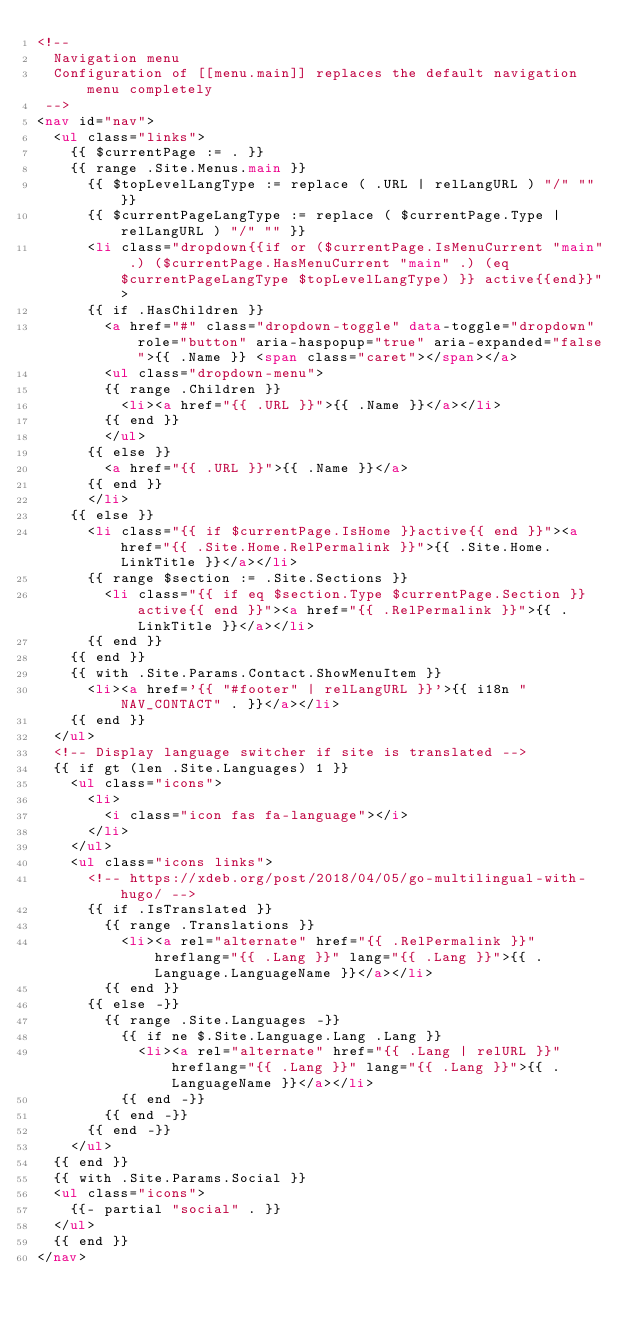Convert code to text. <code><loc_0><loc_0><loc_500><loc_500><_HTML_><!--
  Navigation menu
  Configuration of [[menu.main]] replaces the default navigation menu completely
 -->
<nav id="nav">
  <ul class="links">
    {{ $currentPage := . }}
    {{ range .Site.Menus.main }}
      {{ $topLevelLangType := replace ( .URL | relLangURL ) "/" "" }}
      {{ $currentPageLangType := replace ( $currentPage.Type | relLangURL ) "/" "" }}
      <li class="dropdown{{if or ($currentPage.IsMenuCurrent "main" .) ($currentPage.HasMenuCurrent "main" .) (eq $currentPageLangType $topLevelLangType) }} active{{end}}">
      {{ if .HasChildren }}
        <a href="#" class="dropdown-toggle" data-toggle="dropdown" role="button" aria-haspopup="true" aria-expanded="false">{{ .Name }} <span class="caret"></span></a>
        <ul class="dropdown-menu">
        {{ range .Children }}
          <li><a href="{{ .URL }}">{{ .Name }}</a></li>
        {{ end }}
        </ul>
      {{ else }}
        <a href="{{ .URL }}">{{ .Name }}</a>
      {{ end }}
      </li>
    {{ else }}
      <li class="{{ if $currentPage.IsHome }}active{{ end }}"><a href="{{ .Site.Home.RelPermalink }}">{{ .Site.Home.LinkTitle }}</a></li>
      {{ range $section := .Site.Sections }}
        <li class="{{ if eq $section.Type $currentPage.Section }}active{{ end }}"><a href="{{ .RelPermalink }}">{{ .LinkTitle }}</a></li>
      {{ end }}
    {{ end }}
    {{ with .Site.Params.Contact.ShowMenuItem }}
      <li><a href='{{ "#footer" | relLangURL }}'>{{ i18n "NAV_CONTACT" . }}</a></li>
    {{ end }}
  </ul>
  <!-- Display language switcher if site is translated -->
  {{ if gt (len .Site.Languages) 1 }}
    <ul class="icons">
      <li>
        <i class="icon fas fa-language"></i>
      </li>
    </ul>
    <ul class="icons links">
      <!-- https://xdeb.org/post/2018/04/05/go-multilingual-with-hugo/ -->
      {{ if .IsTranslated }}
        {{ range .Translations }}
          <li><a rel="alternate" href="{{ .RelPermalink }}" hreflang="{{ .Lang }}" lang="{{ .Lang }}">{{ .Language.LanguageName }}</a></li>
        {{ end }}
      {{ else -}}
        {{ range .Site.Languages -}}
          {{ if ne $.Site.Language.Lang .Lang }}
            <li><a rel="alternate" href="{{ .Lang | relURL }}" hreflang="{{ .Lang }}" lang="{{ .Lang }}">{{ .LanguageName }}</a></li>
          {{ end -}}
        {{ end -}}
      {{ end -}}
    </ul>
  {{ end }}
  {{ with .Site.Params.Social }}
  <ul class="icons">
    {{- partial "social" . }}
  </ul>
  {{ end }}
</nav>
</code> 